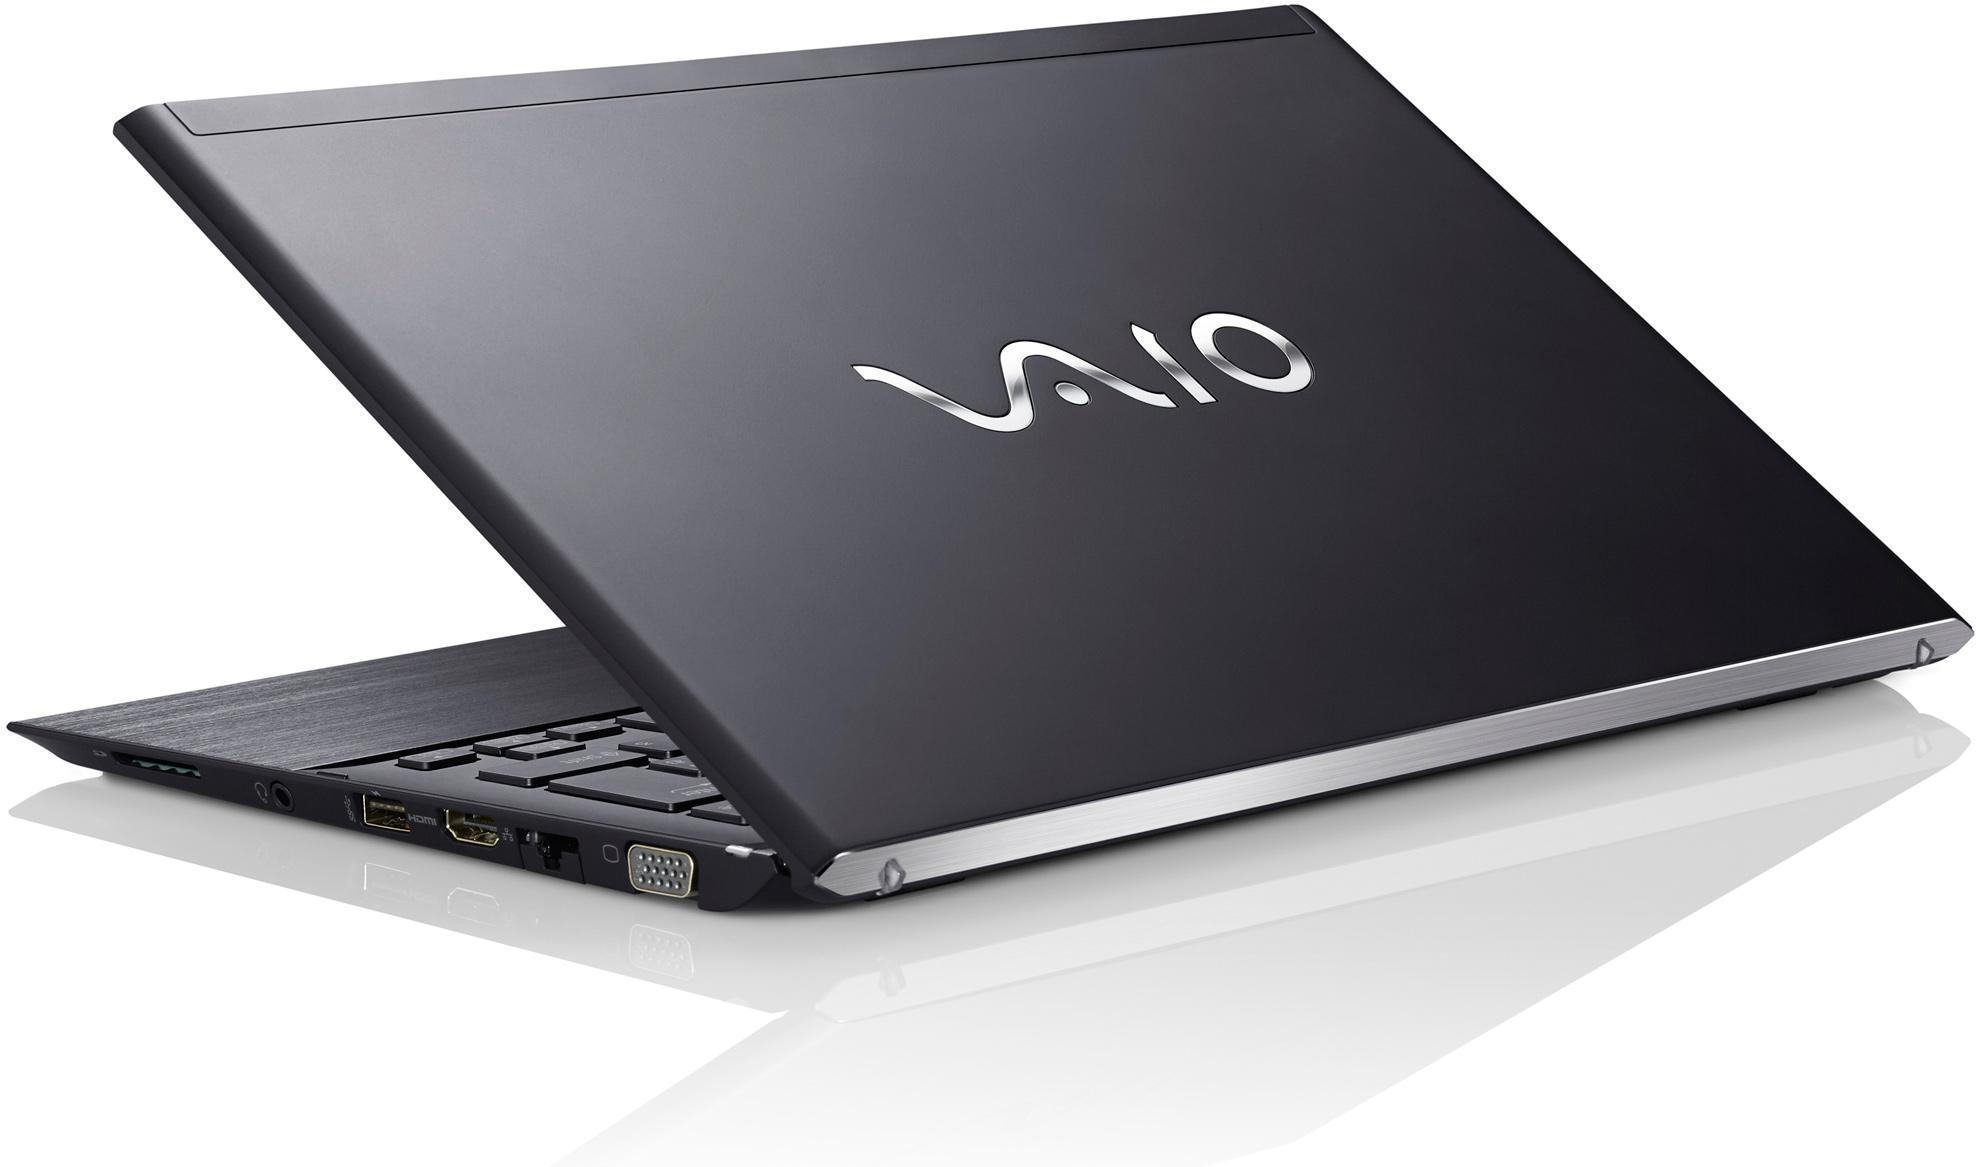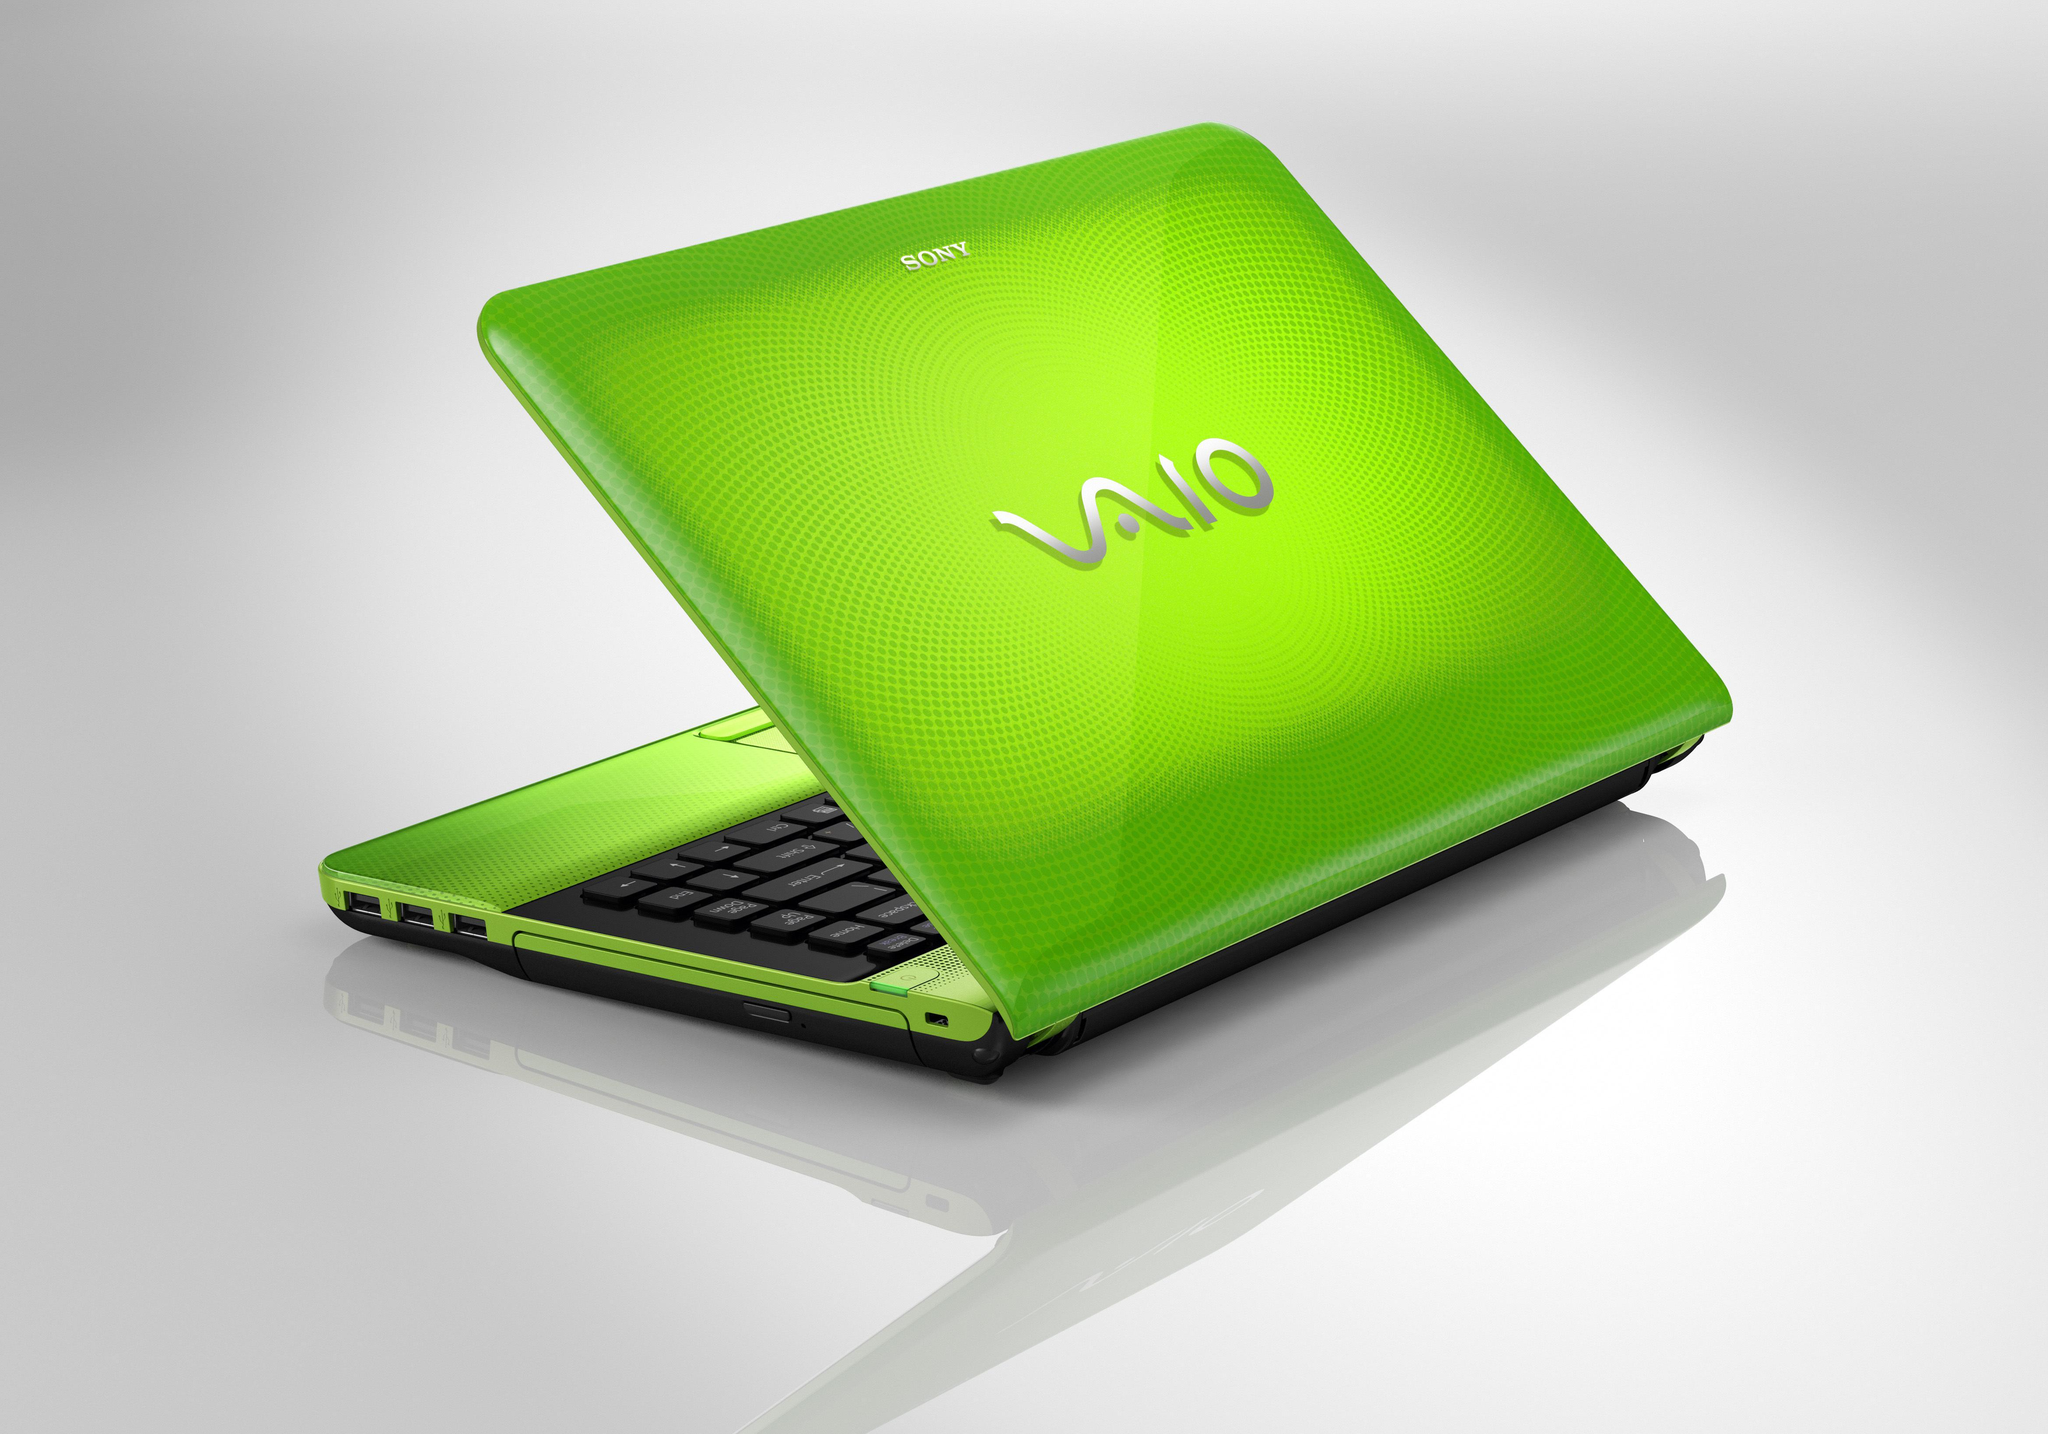The first image is the image on the left, the second image is the image on the right. Analyze the images presented: Is the assertion "There are three laptops, and every visible screen is black." valid? Answer yes or no. No. The first image is the image on the left, the second image is the image on the right. For the images displayed, is the sentence "There is exactly two lap tops in the left image." factually correct? Answer yes or no. No. 